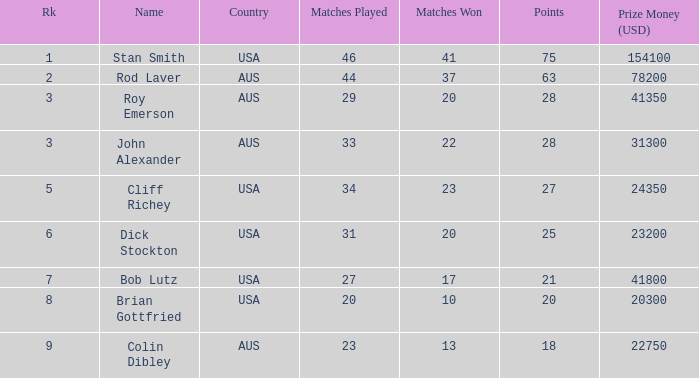Write the full table. {'header': ['Rk', 'Name', 'Country', 'Matches Played', 'Matches Won', 'Points', 'Prize Money (USD)'], 'rows': [['1', 'Stan Smith', 'USA', '46', '41', '75', '154100'], ['2', 'Rod Laver', 'AUS', '44', '37', '63', '78200'], ['3', 'Roy Emerson', 'AUS', '29', '20', '28', '41350'], ['3', 'John Alexander', 'AUS', '33', '22', '28', '31300'], ['5', 'Cliff Richey', 'USA', '34', '23', '27', '24350'], ['6', 'Dick Stockton', 'USA', '31', '20', '25', '23200'], ['7', 'Bob Lutz', 'USA', '27', '17', '21', '41800'], ['8', 'Brian Gottfried', 'USA', '20', '10', '20', '20300'], ['9', 'Colin Dibley', 'AUS', '23', '13', '18', '22750']]} How many wins did the player who took part in 23 matches achieve? 13.0. 